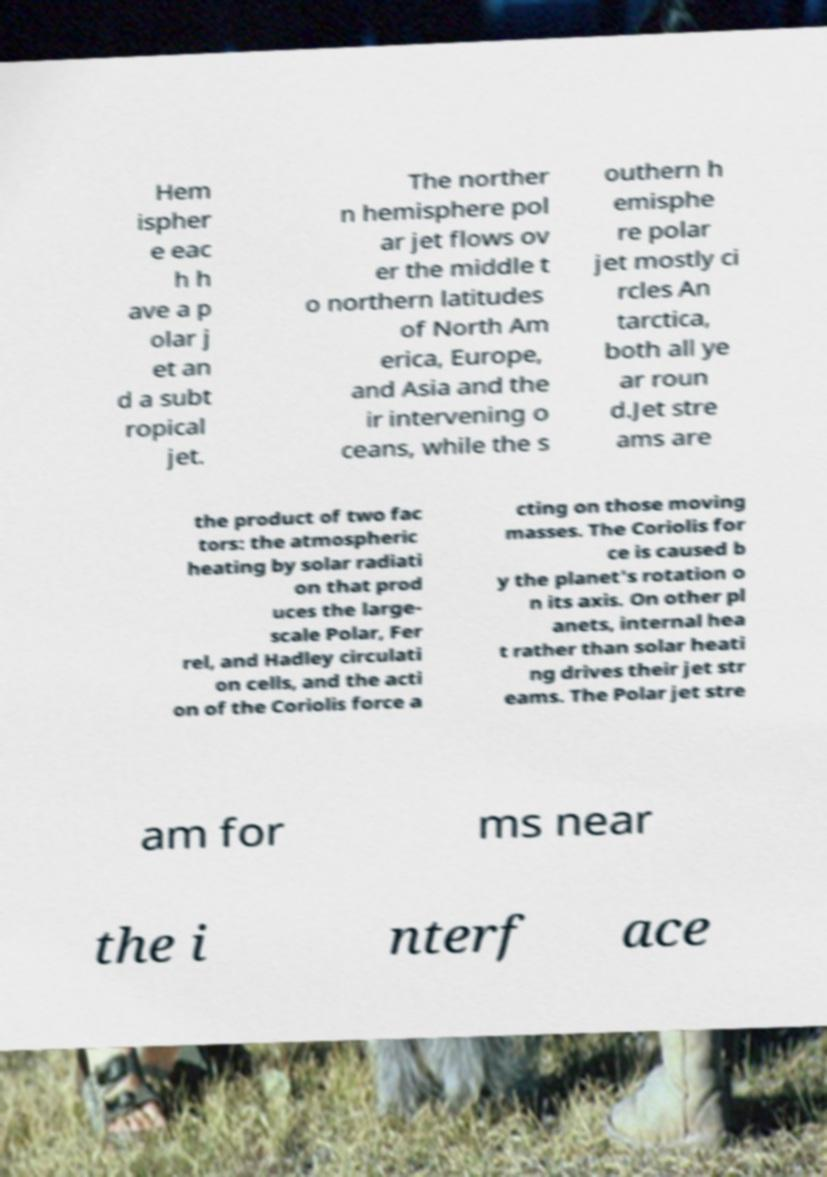Please identify and transcribe the text found in this image. Hem ispher e eac h h ave a p olar j et an d a subt ropical jet. The norther n hemisphere pol ar jet flows ov er the middle t o northern latitudes of North Am erica, Europe, and Asia and the ir intervening o ceans, while the s outhern h emisphe re polar jet mostly ci rcles An tarctica, both all ye ar roun d.Jet stre ams are the product of two fac tors: the atmospheric heating by solar radiati on that prod uces the large- scale Polar, Fer rel, and Hadley circulati on cells, and the acti on of the Coriolis force a cting on those moving masses. The Coriolis for ce is caused b y the planet's rotation o n its axis. On other pl anets, internal hea t rather than solar heati ng drives their jet str eams. The Polar jet stre am for ms near the i nterf ace 